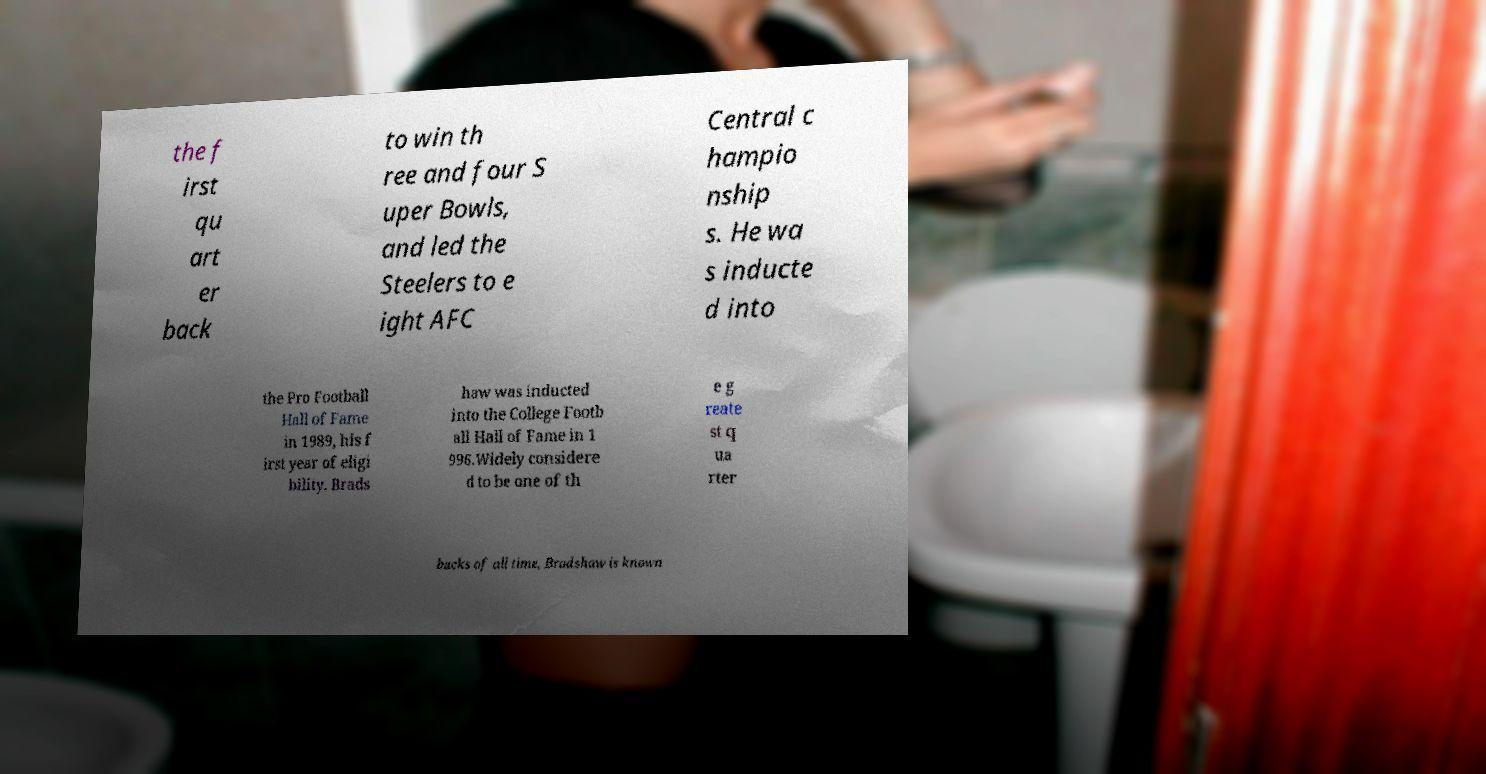Please identify and transcribe the text found in this image. the f irst qu art er back to win th ree and four S uper Bowls, and led the Steelers to e ight AFC Central c hampio nship s. He wa s inducte d into the Pro Football Hall of Fame in 1989, his f irst year of eligi bility. Brads haw was inducted into the College Footb all Hall of Fame in 1 996.Widely considere d to be one of th e g reate st q ua rter backs of all time, Bradshaw is known 